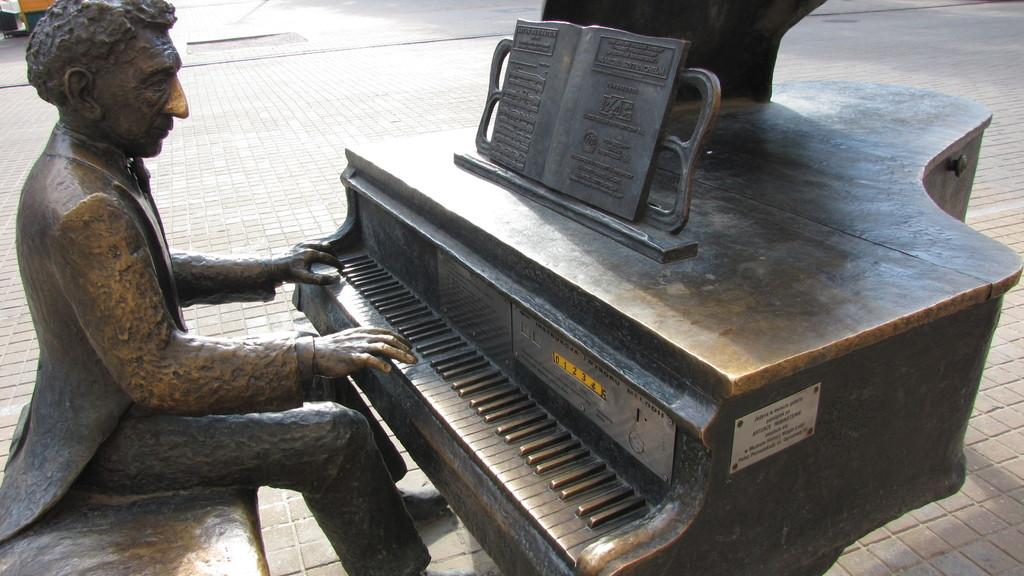What is the main subject of the image? The main subject of the image is a statue of a person. What is the statue doing? The statue is playing a keyboard. Is there anything placed on the keyboard? Yes, there is a book on the keyboard. What type of surface is at the bottom of the image? There is a pavement at the bottom of the image. Where is the store located in the image? There is no store visible in the image. 